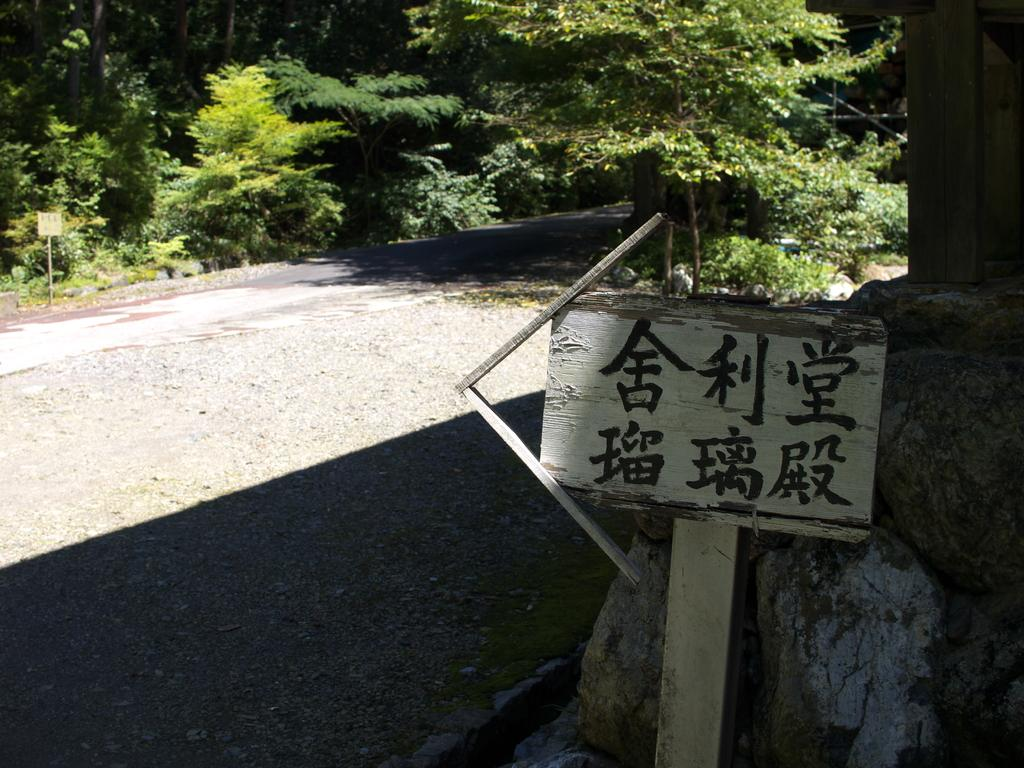What is written or displayed on the signboard in the image? There is a signboard with text in the image, but the specific content is not mentioned in the facts. What type of natural elements can be seen in the image? There are rocks, plants, and a group of trees visible in the image. What is the purpose of the board in the image? The purpose of the board is not mentioned in the facts, but it is present in the image. How many points are visible on the rod in the image? There is no rod or points present in the image. Is there a camp visible in the image? There is no camp present in the image. 